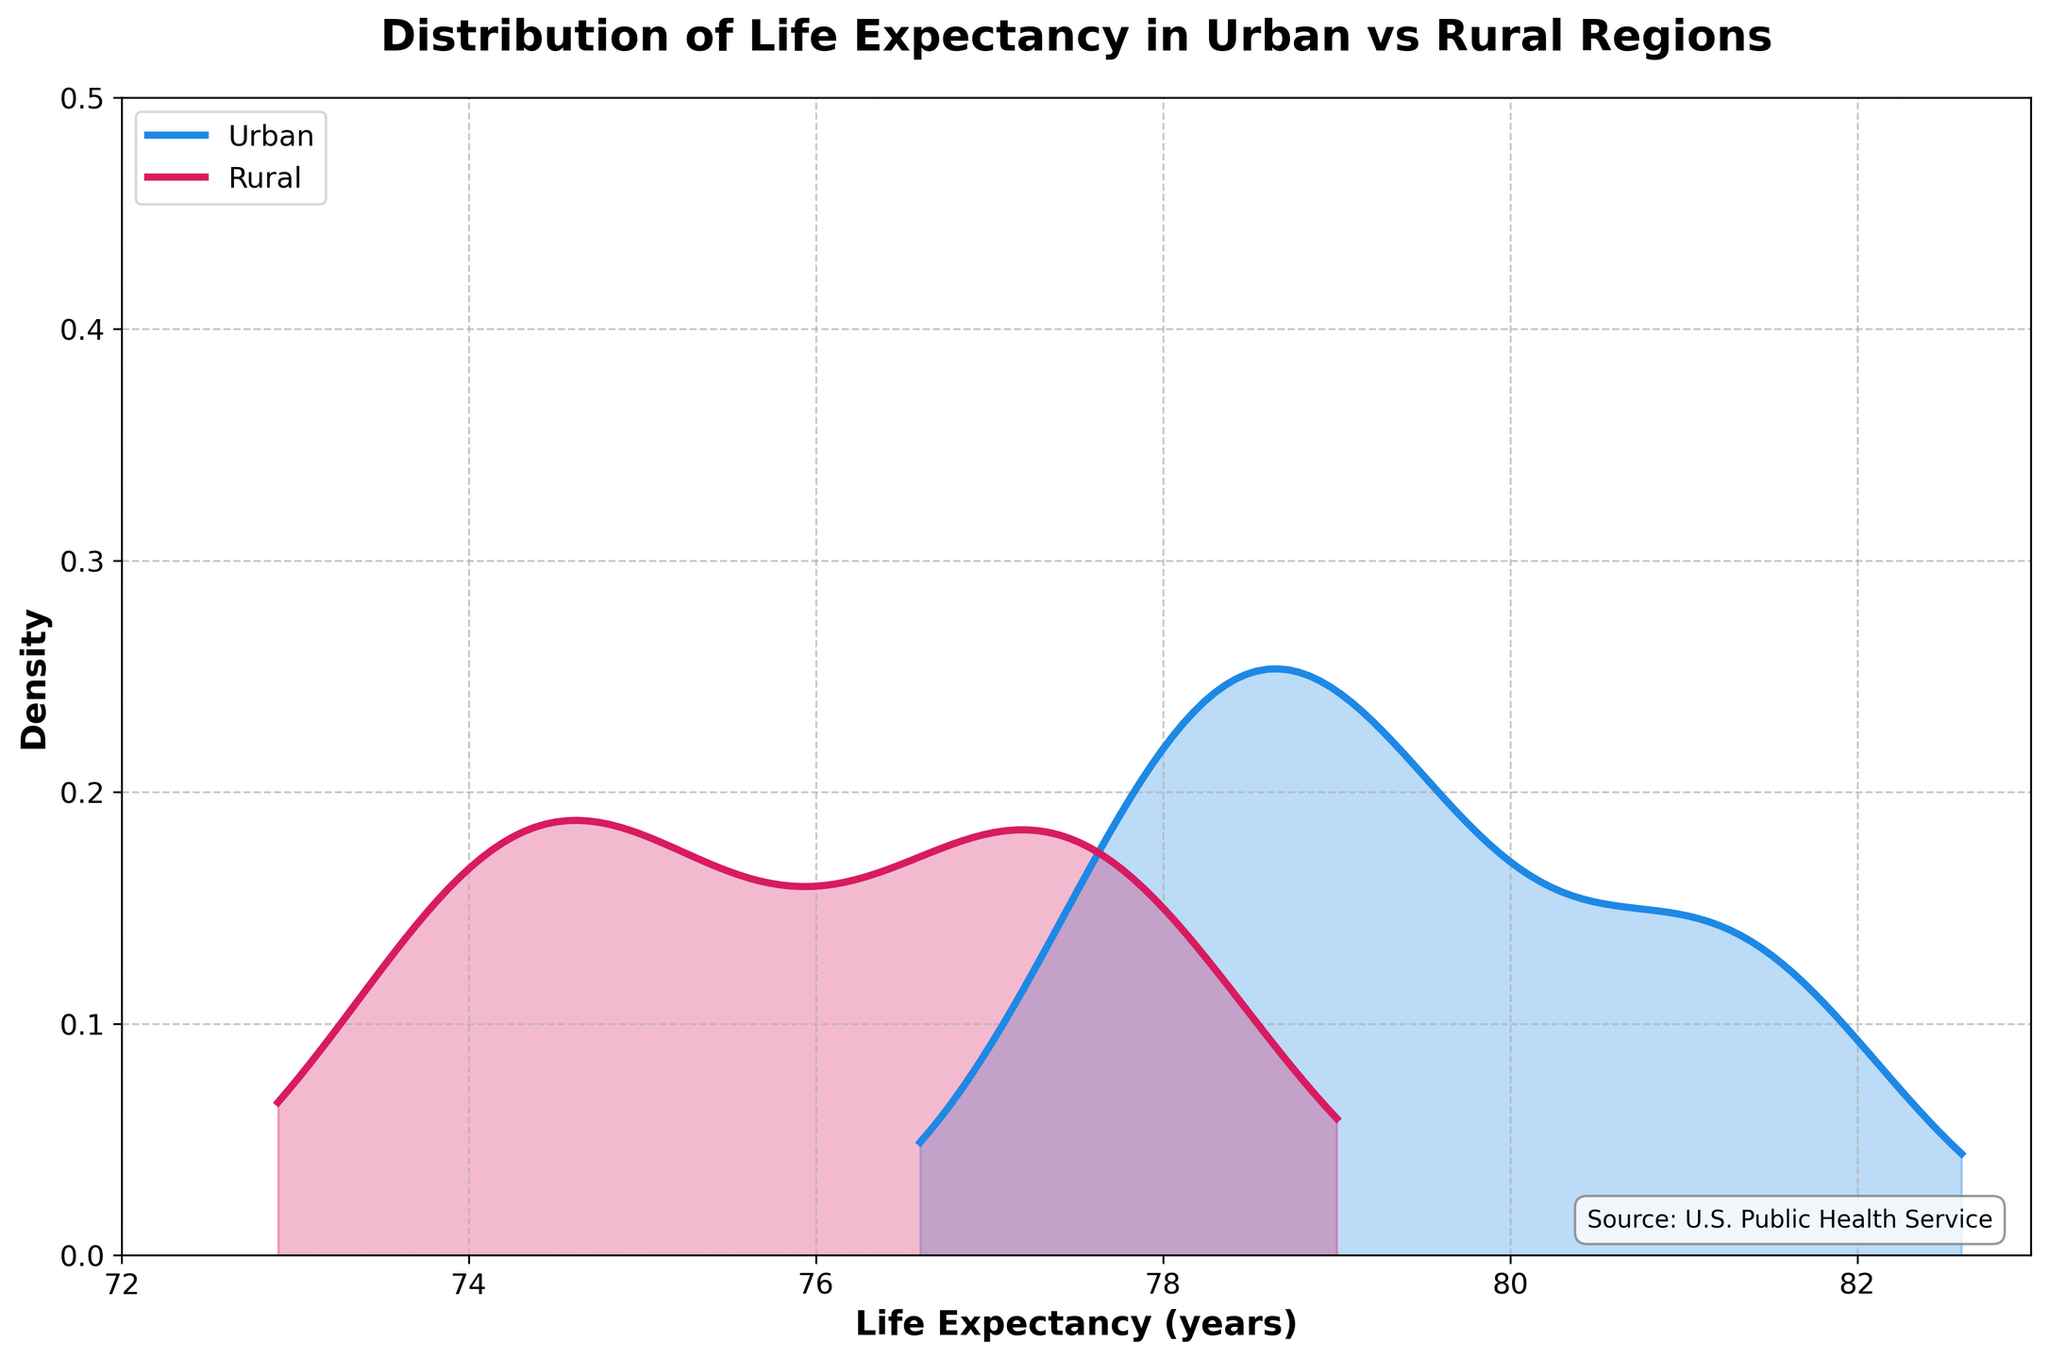What is the title of the plot? The title is usually placed above the plot and provides a brief description of what the plot is about. In this case, it reads, "Distribution of Life Expectancy in Urban vs Rural Regions".
Answer: Distribution of Life Expectancy in Urban vs Rural Regions Which region has a higher peak in its density curve, Urban or Rural? From the plot, we observe that the Urban region has a higher peak in the density curve compared to the Rural region. This indicates a higher concentration of life expectancy values around the peak for Urban areas.
Answer: Urban What colors represent the Urban and Rural regions in the plot? The Urban region is represented by a blue curve, while the Rural region is represented by a red curve. These colors help differentiate the two regions.
Answer: Blue for Urban, Red for Rural What is the estimated life expectancy range for the Urban region where the density is relatively high? Observing the plot, the Gaussian KDE curve for the Urban region shows a high density around the life expectancy range of approximately 77 to 82 years.
Answer: 77 to 82 years Which region shows a broader distribution of life expectancy, Urban or Rural? The Rural region's density curve is more spread out compared to the Urban region, indicating a broader distribution of life expectancy values.
Answer: Rural Around which life expectancy value does the Rural region have its highest density? The highest peak of the density curve for the Rural region is around a life expectancy of approximately 77 years.
Answer: 77 years Does the plot have any annotations, and if so, what do they indicate? Yes, the plot has an annotation at the bottom right corner which mentions the source of the data: "Source: U.S. Public Health Service".
Answer: Source: U.S. Public Health Service Between which life expectancy values does the plot's x-axis range? The x-axis ranges from 72 to 83 years, showing the variation in life expectancy for both Urban and Rural regions.
Answer: 72 to 83 years How does the variance in life expectancy compare between the Urban and Rural regions based on the density plot? The Urban region shows a more concentrated (narrower) distribution, implying lesser variance in life expectancy. In contrast, the Rural region's distribution is wider, indicating higher variance.
Answer: Urban has lesser variance, Rural has higher variance What is the lower bound for the y-axis (density) in the plot? The lower bound for the y-axis (density) is 0, indicating the minimum possible density value in the plot.
Answer: 0 